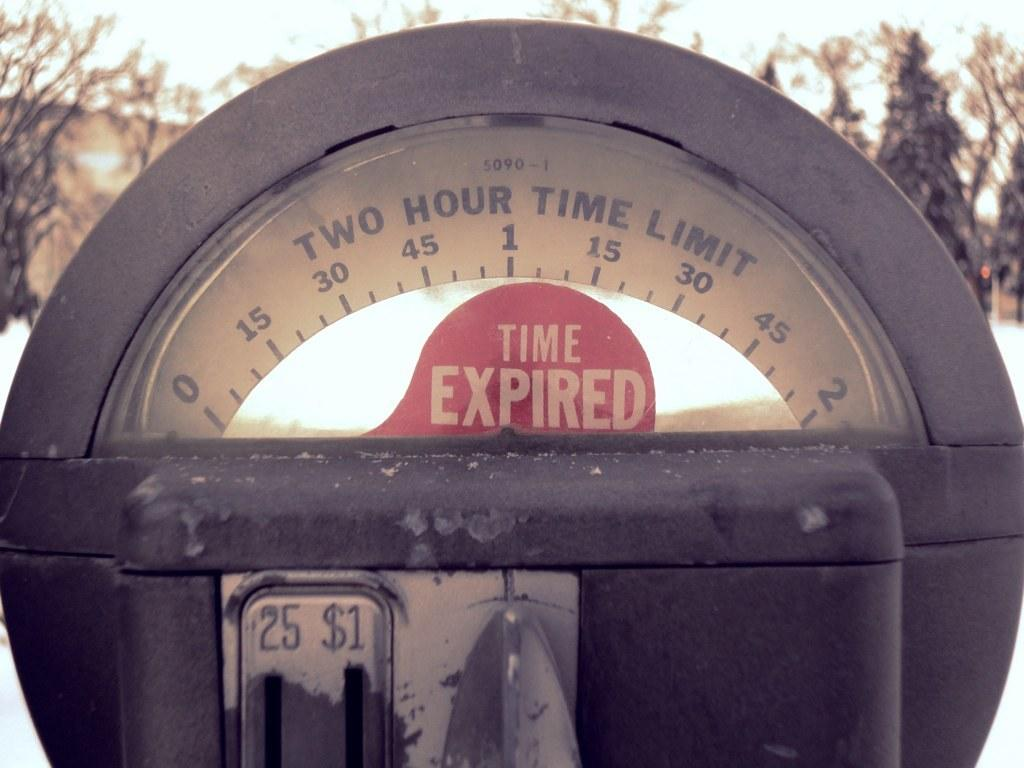<image>
Create a compact narrative representing the image presented. A parking meter has a red indicator that the time has expired. 